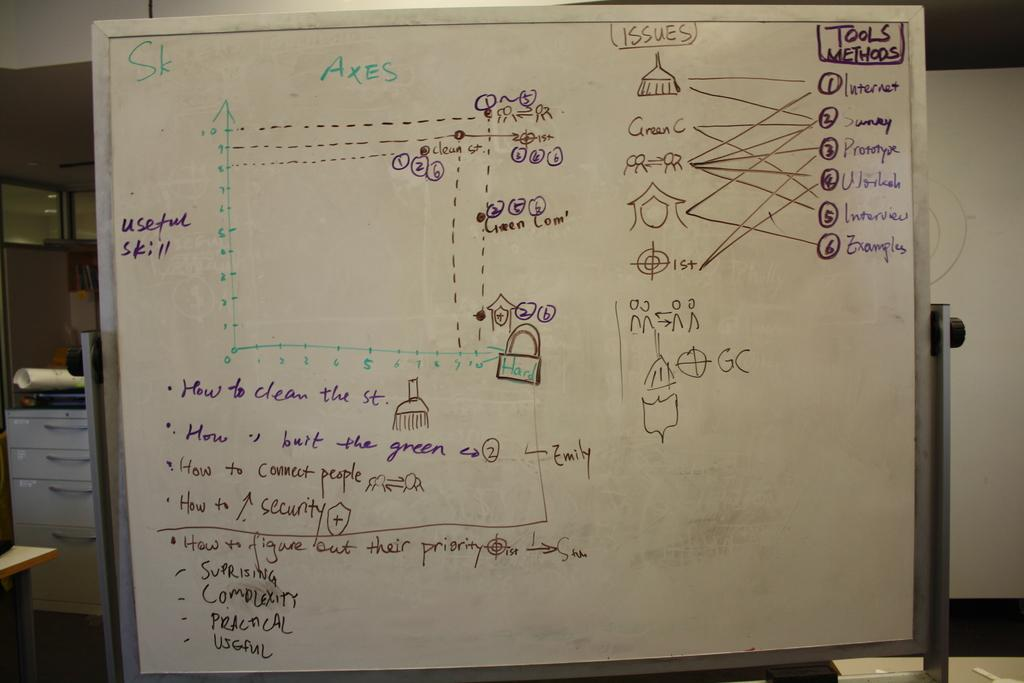<image>
Describe the image concisely. Some type of drawing demonstration with the words, Tools Methods, written in the top right corner. 